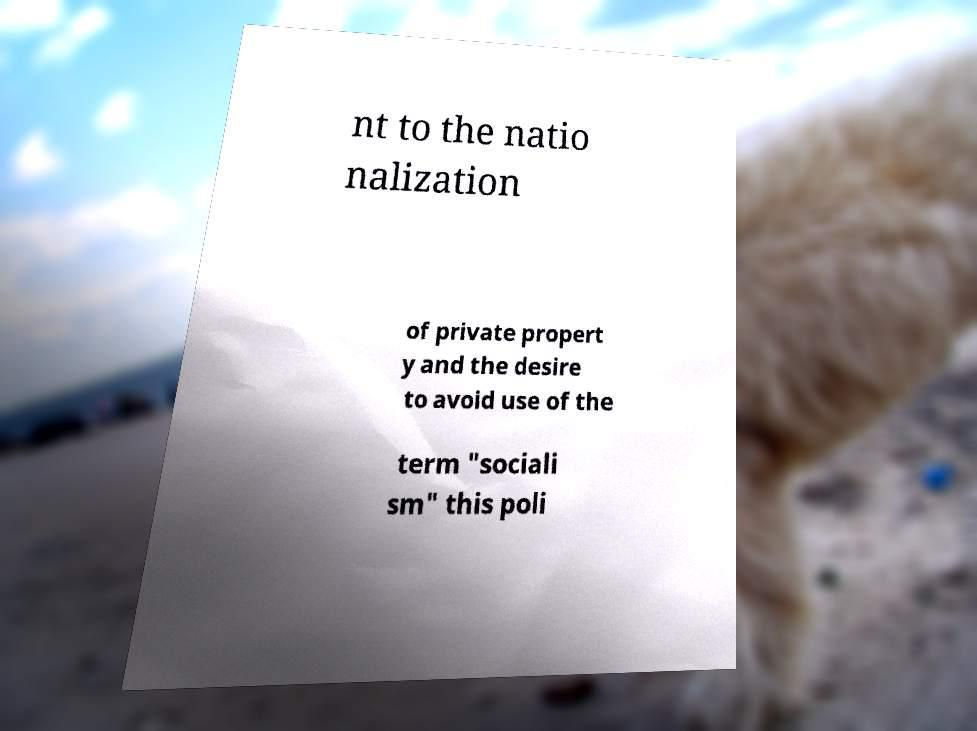Please read and relay the text visible in this image. What does it say? nt to the natio nalization of private propert y and the desire to avoid use of the term "sociali sm" this poli 